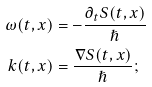Convert formula to latex. <formula><loc_0><loc_0><loc_500><loc_500>\omega ( t , x ) & = - \frac { \partial _ { t } S ( t , x ) } { \hslash } \\ k ( t , x ) & = \frac { \nabla S ( t , x ) } { \hslash } ;</formula> 